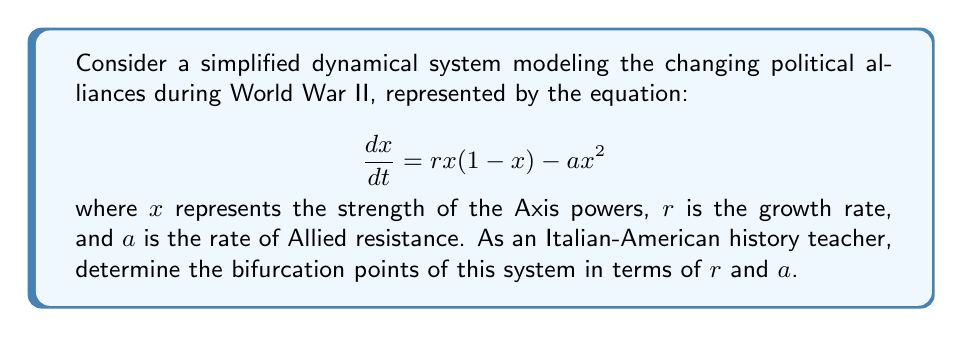Can you solve this math problem? 1) First, we need to find the equilibrium points of the system by setting $\frac{dx}{dt} = 0$:

   $$rx(1-x) - ax^2 = 0$$

2) Factor out $x$:

   $$x(r(1-x) - ax) = 0$$

3) Solve for $x$:
   
   $x = 0$ or $r(1-x) - ax = 0$

4) For the second equation:
   
   $r - rx - ax = 0$
   $r = x(r + a)$
   $x = \frac{r}{r+a}$

5) So, the equilibrium points are $x_1 = 0$ and $x_2 = \frac{r}{r+a}$

6) To find the bifurcation points, we need to determine when these equilibrium points change stability. This occurs when:

   $$x_1 = x_2$$

   $$0 = \frac{r}{r+a}$$

7) This equation is satisfied when $r = 0$. This is our bifurcation point.

8) To verify, we can check the stability of the equilibrium points:

   The derivative of $\frac{dx}{dt}$ with respect to $x$ is:
   
   $$\frac{d}{dx}(\frac{dx}{dt}) = r(1-2x) - 2ax$$

9) At $x_1 = 0$, this becomes $r$. The point is stable when $r < 0$ and unstable when $r > 0$.

10) At $x_2 = \frac{r}{r+a}$, the stability changes when $r = 0$.

Therefore, the bifurcation point occurs at $r = 0$, representing a transcritical bifurcation where the two equilibrium points exchange stability.
Answer: $r = 0$ 